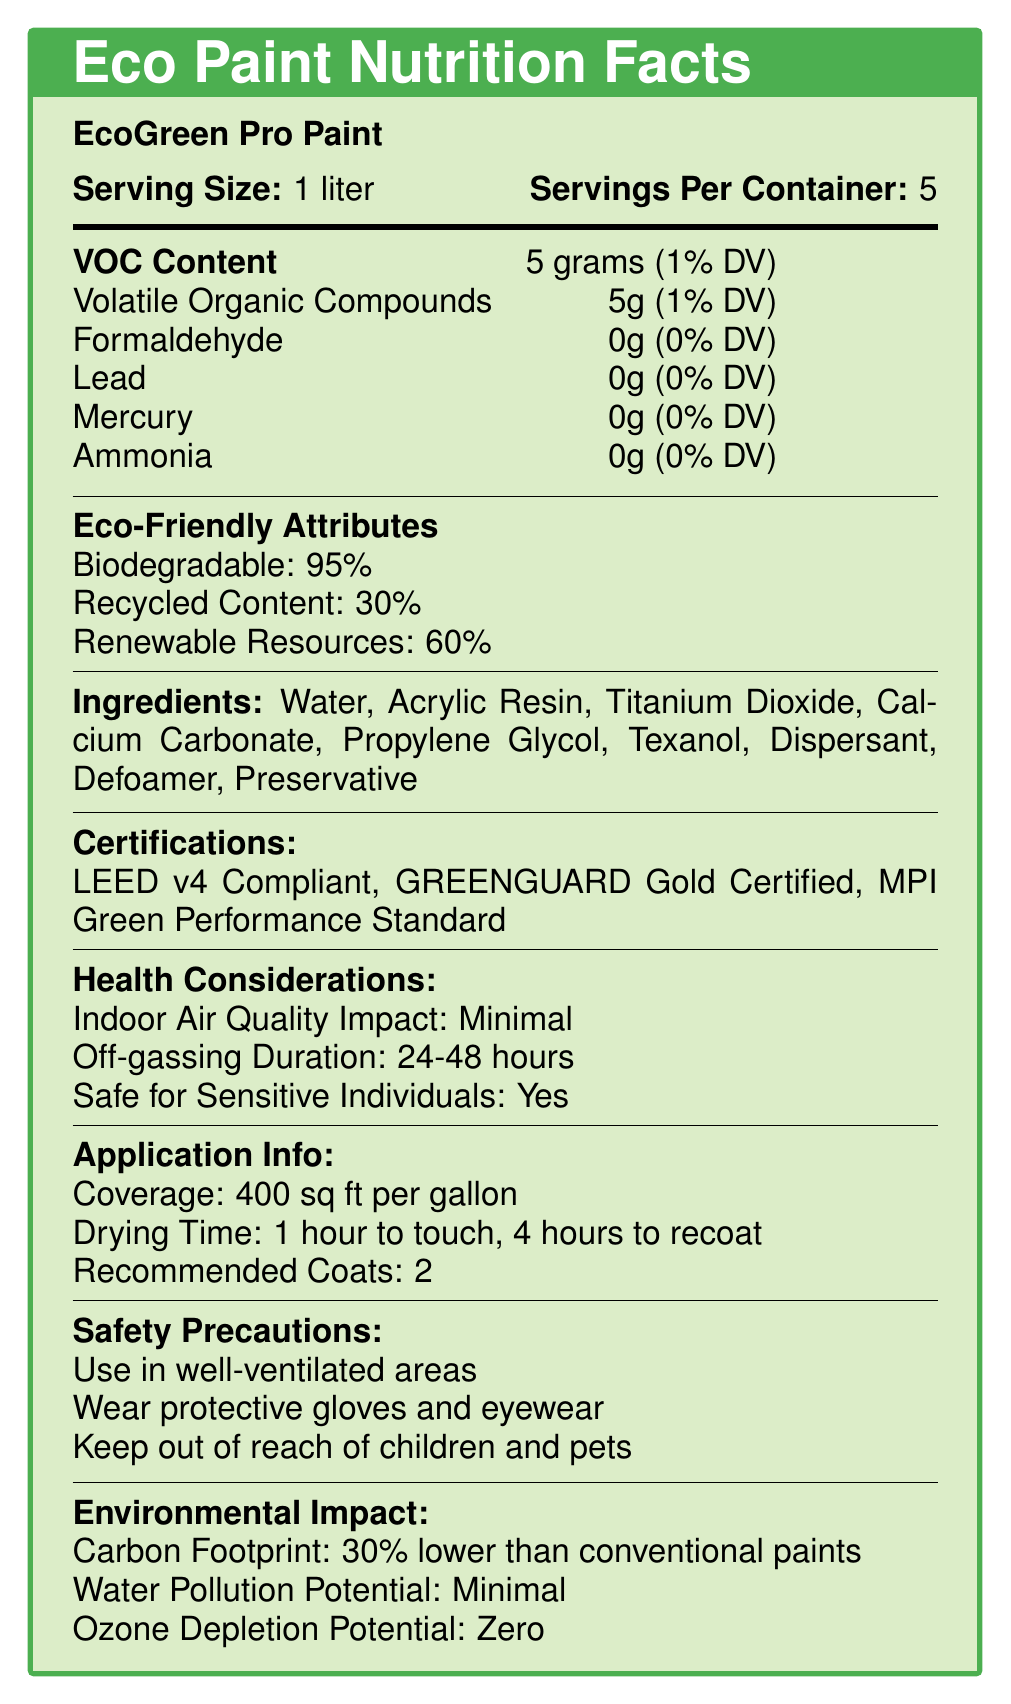What is the VOC content of EcoGreen Pro Paint? The document specifies that the VOC content is 5 grams per serving, which is 1% of the daily value.
Answer: 5 grams (1% DV) How many servings are there per container of EcoGreen Pro Paint? The document states that there are 5 servings per container.
Answer: 5 What is the off-gassing duration for EcoGreen Pro Paint? According to the document, the off-gassing duration is 24-48 hours.
Answer: 24-48 hours Can EcoGreen Pro Paint be safely used by sensitive individuals? The document mentions that the paint is safe for sensitive individuals.
Answer: Yes What are the main ingredients in EcoGreen Pro Paint? The document lists these ingredients explicitly.
Answer: Water, Acrylic Resin, Titanium Dioxide, Calcium Carbonate, Propylene Glycol, Texanol, Dispersant, Defoamer, Preservative What is the drying time for EcoGreen Pro Paint to touch? A. 30 minutes B. 1 hour C. 2 hours D. 4 hours The drying time to touch is specified as 1 hour.
Answer: B Which of the following certifications does EcoGreen Pro Paint have? I. LEED v4 Compliant II. GREENGUARD Gold Certified III. MPI Green Performance Standard IV. Energy Star The document lists LEED v4 Compliant, GREENGUARD Gold Certified, and MPI Green Performance Standard as certifications.
Answer: I, II, III Does EcoGreen Pro Paint contain any lead? The document clearly states that the amount of lead is 0 grams.
Answer: No Summarize the eco-friendly attributes of EcoGreen Pro Paint. The document highlights that EcoGreen Pro Paint is 95% biodegradable, contains 30% recycled content, and is made of 60% renewable resources.
Answer: Biodegradable: 95%, Recycled Content: 30%, Renewable Resources: 60% What is the carbon footprint of EcoGreen Pro Paint compared to conventional paints? The environmental impact section indicates that the carbon footprint is 30% lower than that of conventional paints.
Answer: 30% lower What safety precautions should be taken when using EcoGreen Pro Paint? The document lists these safety precautions explicitly.
Answer: Use in well-ventilated areas, wear protective gloves and eyewear, keep out of reach of children and pets Is EcoGreen Pro Paint compliant with VOC regulations? The document provides VOC content information but does not explicitly state compliance with specific VOC regulations.
Answer: Cannot be determined 